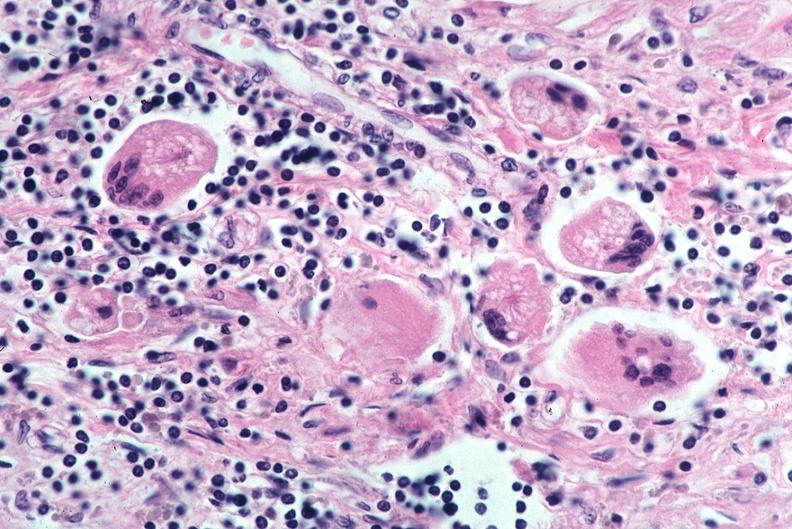s respiratory present?
Answer the question using a single word or phrase. Yes 